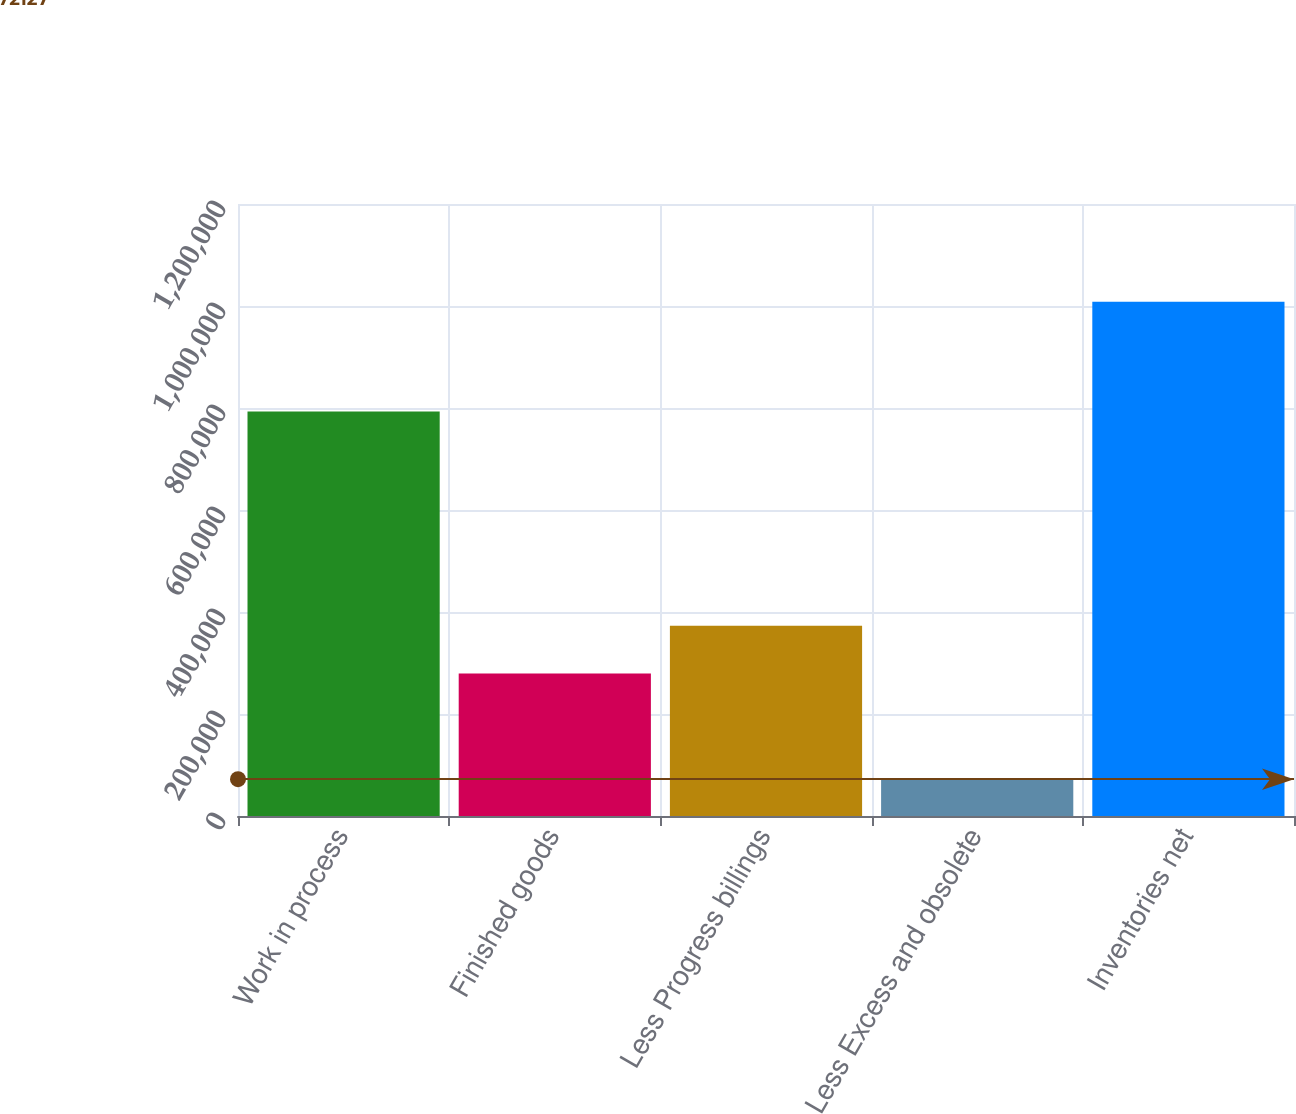Convert chart. <chart><loc_0><loc_0><loc_500><loc_500><bar_chart><fcel>Work in process<fcel>Finished goods<fcel>Less Progress billings<fcel>Less Excess and obsolete<fcel>Inventories net<nl><fcel>793053<fcel>279267<fcel>372892<fcel>72127<fcel>1.00838e+06<nl></chart> 